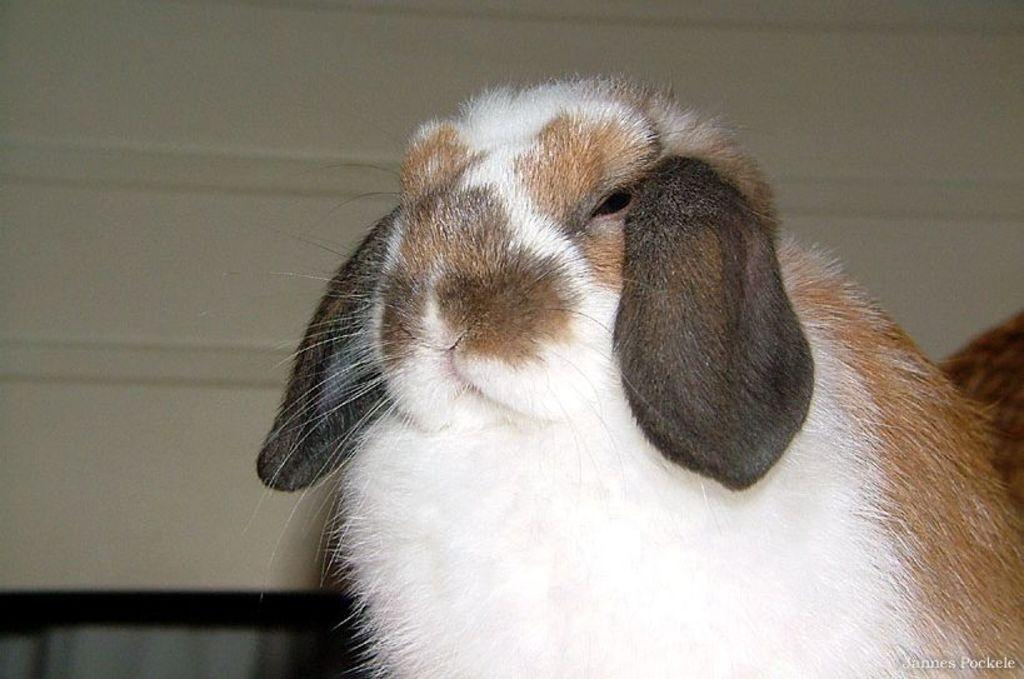What type of animal is in the image? There is a fluffy rabbit in the image. What can be seen in the background of the image? There is a wall in the background of the image. Is there any text or logo visible in the image? Yes, there is a watermark at the bottom right side of the image. How many mice are hiding behind the rabbit in the image? There are no mice present in the image; it only features a fluffy rabbit. 